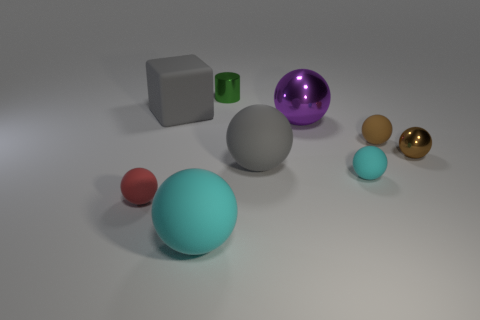Subtract all cyan spheres. How many spheres are left? 5 Subtract all large gray balls. How many balls are left? 6 Subtract all purple balls. Subtract all cyan cubes. How many balls are left? 6 Add 1 gray spheres. How many objects exist? 10 Subtract all spheres. How many objects are left? 2 Add 8 purple metal things. How many purple metal things are left? 9 Add 3 brown rubber balls. How many brown rubber balls exist? 4 Subtract 1 purple balls. How many objects are left? 8 Subtract all spheres. Subtract all gray shiny balls. How many objects are left? 2 